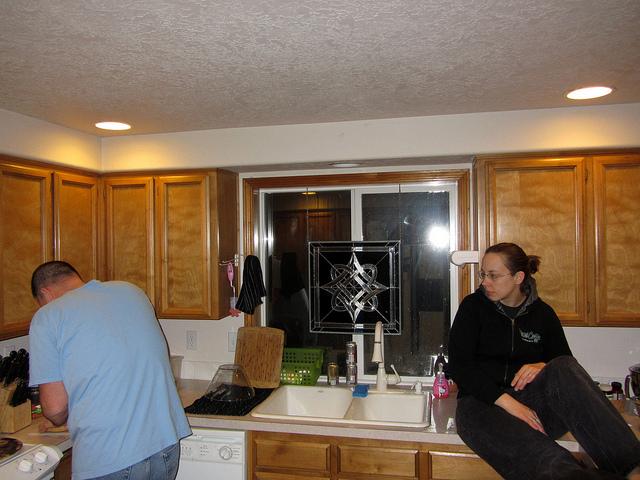Is this in a home?
Write a very short answer. Yes. What is she looking at?
Quick response, please. Man. Is this person happy?
Short answer required. No. What is the cutting board made of?
Answer briefly. Wood. Where is the girl sitting?
Answer briefly. Counter. 